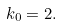<formula> <loc_0><loc_0><loc_500><loc_500>k _ { 0 } = 2 .</formula> 